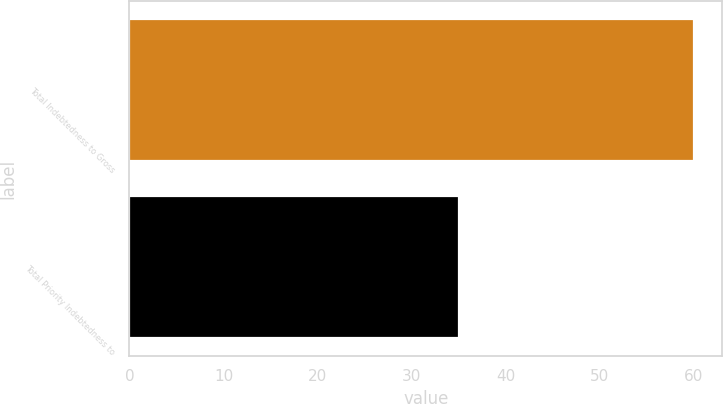<chart> <loc_0><loc_0><loc_500><loc_500><bar_chart><fcel>Total Indebtedness to Gross<fcel>Total Priority Indebtedness to<nl><fcel>60<fcel>35<nl></chart> 